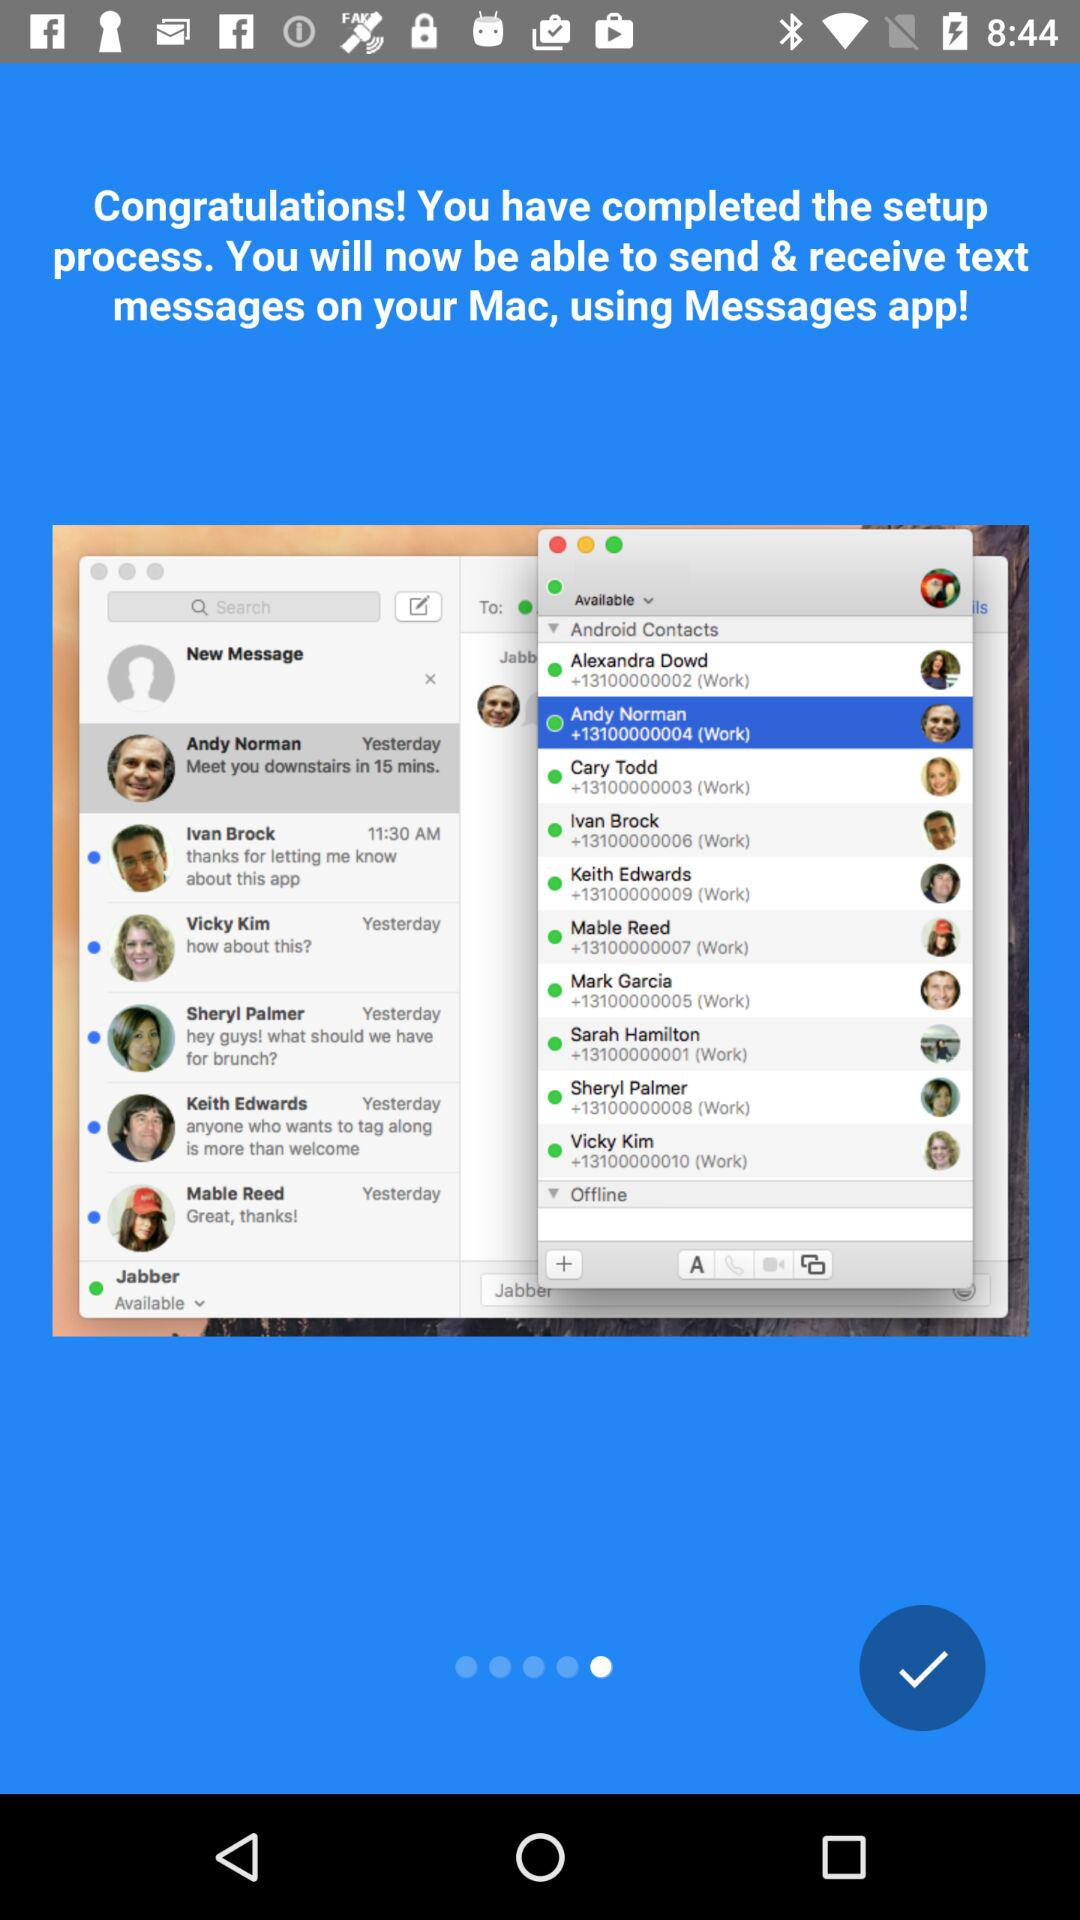What is the name of the application? The name of the application is "Messages". 